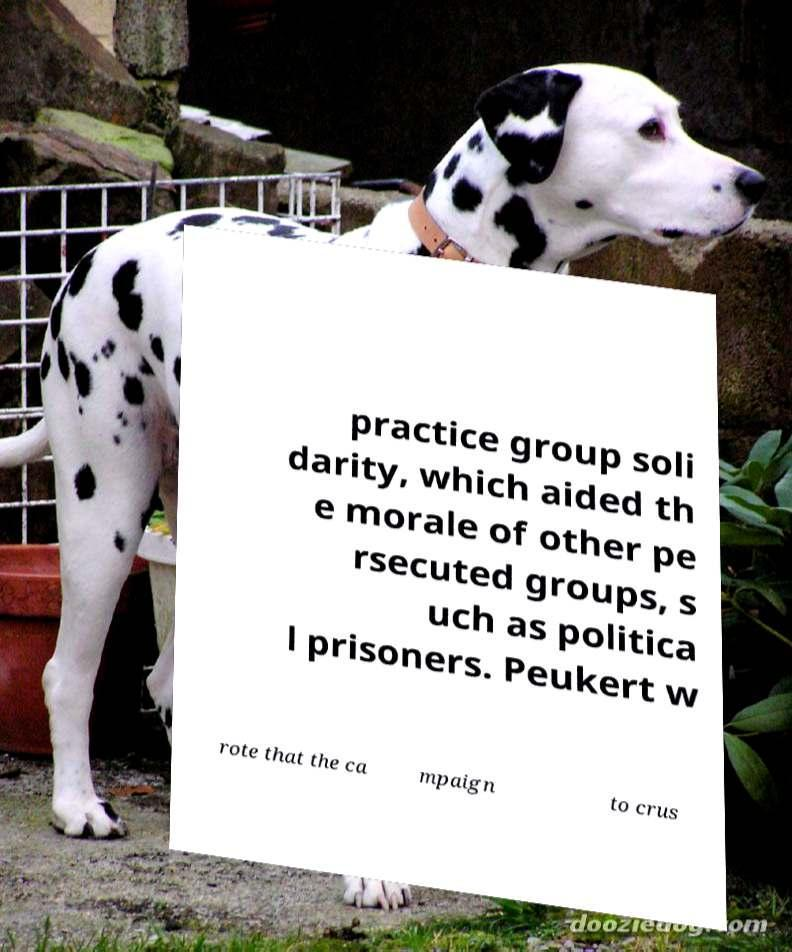Can you read and provide the text displayed in the image?This photo seems to have some interesting text. Can you extract and type it out for me? practice group soli darity, which aided th e morale of other pe rsecuted groups, s uch as politica l prisoners. Peukert w rote that the ca mpaign to crus 